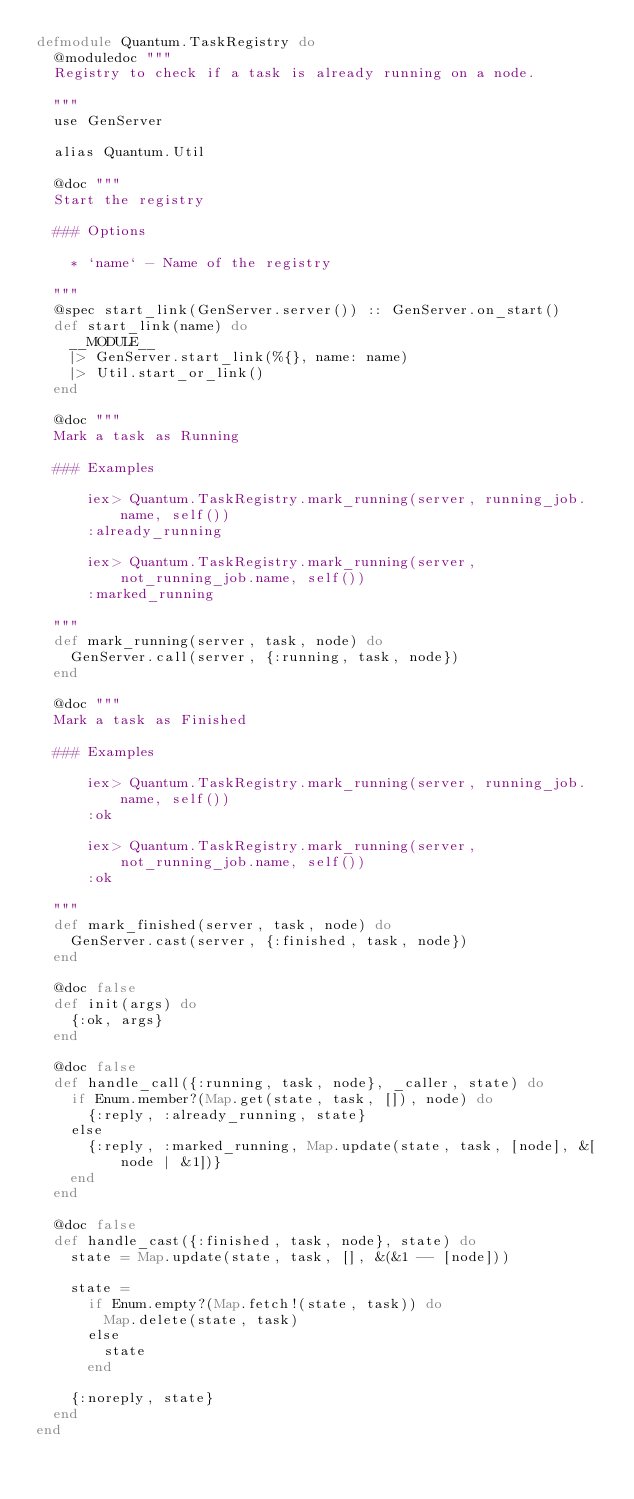<code> <loc_0><loc_0><loc_500><loc_500><_Elixir_>defmodule Quantum.TaskRegistry do
  @moduledoc """
  Registry to check if a task is already running on a node.

  """
  use GenServer

  alias Quantum.Util

  @doc """
  Start the registry

  ### Options

    * `name` - Name of the registry

  """
  @spec start_link(GenServer.server()) :: GenServer.on_start()
  def start_link(name) do
    __MODULE__
    |> GenServer.start_link(%{}, name: name)
    |> Util.start_or_link()
  end

  @doc """
  Mark a task as Running

  ### Examples

      iex> Quantum.TaskRegistry.mark_running(server, running_job.name, self())
      :already_running

      iex> Quantum.TaskRegistry.mark_running(server, not_running_job.name, self())
      :marked_running

  """
  def mark_running(server, task, node) do
    GenServer.call(server, {:running, task, node})
  end

  @doc """
  Mark a task as Finished

  ### Examples

      iex> Quantum.TaskRegistry.mark_running(server, running_job.name, self())
      :ok

      iex> Quantum.TaskRegistry.mark_running(server, not_running_job.name, self())
      :ok

  """
  def mark_finished(server, task, node) do
    GenServer.cast(server, {:finished, task, node})
  end

  @doc false
  def init(args) do
    {:ok, args}
  end

  @doc false
  def handle_call({:running, task, node}, _caller, state) do
    if Enum.member?(Map.get(state, task, []), node) do
      {:reply, :already_running, state}
    else
      {:reply, :marked_running, Map.update(state, task, [node], &[node | &1])}
    end
  end

  @doc false
  def handle_cast({:finished, task, node}, state) do
    state = Map.update(state, task, [], &(&1 -- [node]))

    state =
      if Enum.empty?(Map.fetch!(state, task)) do
        Map.delete(state, task)
      else
        state
      end

    {:noreply, state}
  end
end
</code> 